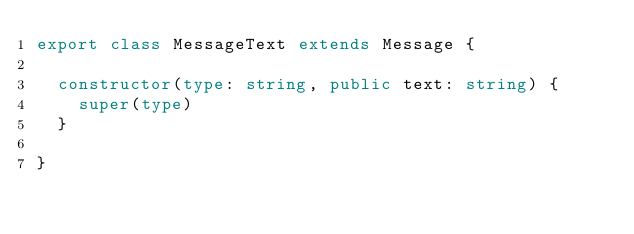Convert code to text. <code><loc_0><loc_0><loc_500><loc_500><_TypeScript_>export class MessageText extends Message {

  constructor(type: string, public text: string) {
    super(type)
  }

}
</code> 